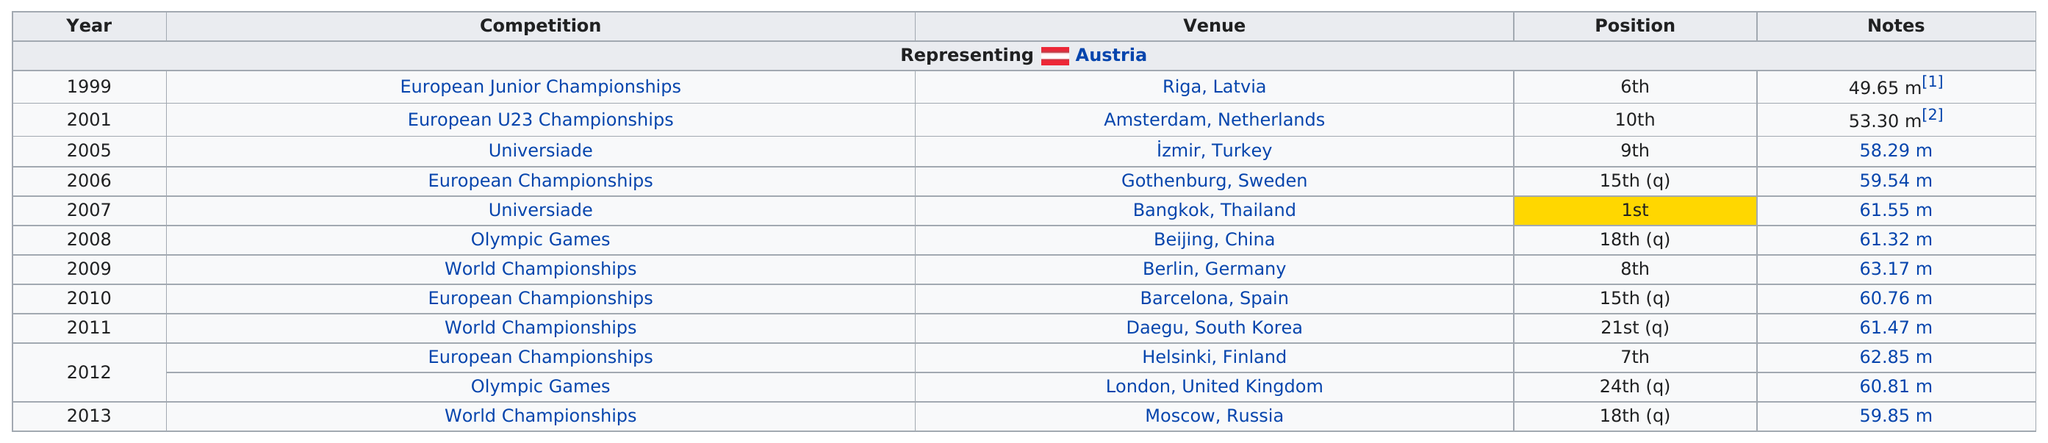Mention a couple of crucial points in this snapshot. Out of the 5 times the position was higher than 10, it was earned 5 times. He has competed in three world championships. In 2001, a distance of only 53.30 meters was achieved. The last competition that the individual participated in before the 2012 Olympics was the European Championships, which took place prior to the games. The European Junior Championships has been listed as the competition a total of 1 time. 